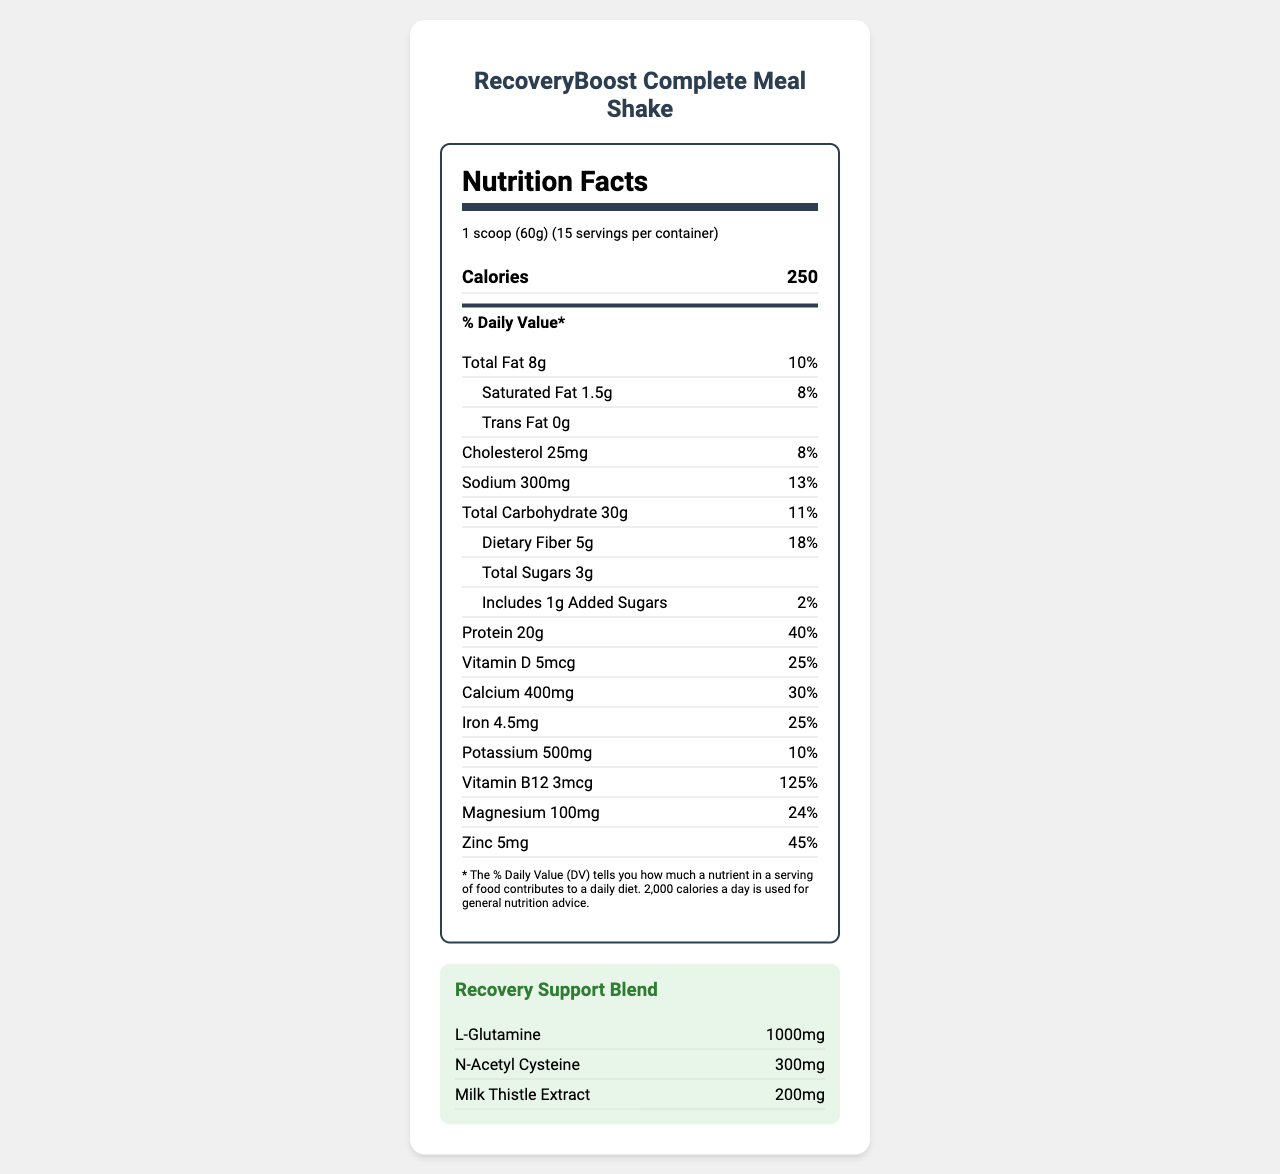how many servings are in each container? The document states that there are "15 servings per container."
Answer: 15 what is the recommended serving size? The serving size is specified as "1 scoop (60g)."
Answer: 1 scoop (60g) how many calories are in a serving? The number of calories per serving is listed as 250.
Answer: 250 how much protein is in one serving? The document states that there are 20g of protein per serving.
Answer: 20g how much dietary fiber is in each serving? Each serving contains 5g of dietary fiber.
Answer: 5g which nutrient has the highest daily value percentage? A. Protein B. Vitamin B12 C. Calcium D. Vitamin D Vitamin B12 has the highest daily value percentage at 125%.
Answer: B what is the total amount of sugars in a serving? The total sugars in a serving are 3g.
Answer: 3g of the following, which is NOT listed as an ingredient? A. Pea protein isolate B. Milk protein C. Stevia leaf extract D. Oat flour Milk protein is not listed as an ingredient; all others are included.
Answer: B does the product contain any trans fat? The document states that the trans fat content is 0g.
Answer: No what is the primary purpose of this product? The product is specially formulated to support individuals in addiction treatment programs, as indicated in the product description.
Answer: To support individuals in addiction treatment programs describe the nutrient profile of the RecoveryBoost Complete Meal Shake The document provides comprehensive details on all the nutrients, their amounts, and daily value percentages per serving, showcasing it as a balanced meal replacement aiming to support recovery and overall health.
Answer: The RecoveryBoost Complete Meal Shake is a balanced meal replacement specifically formulated for individuals in addiction treatment programs. It contains 250 calories per serving, with significant amounts of protein (20g), dietary fiber (5g), and a blend of vitamins and minerals. It also features a unique recovery support blend that includes L-Glutamine, N-Acetyl Cysteine, and Milk Thistle Extract. what is the daily value percentage for calcium? The daily value percentage for calcium is listed as 30%.
Answer: 30% how are omega-3 fatty acids represented in the document? The amount of omega-3 fatty acids in each serving is stated as 1g.
Answer: 1g what is the main allergen in the product? The allergen information specifies that the product contains tree nuts (coconut).
Answer: Tree nuts (coconut) how should the product be stored after opening? The storage instructions advise to store the product in a cool, dry place and to seal the bag tightly after opening.
Answer: Store in a cool, dry place and seal the bag tightly after opening does the product contain gluten? The document does not explicitly state whether the product contains gluten or not. It mentions that it is manufactured in a facility that processes wheat, but it does not clarify if the product itself contains gluten.
Answer: Not enough information 